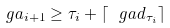Convert formula to latex. <formula><loc_0><loc_0><loc_500><loc_500>\ g a _ { i + 1 } \geq \tau _ { i } + \lceil \ g a d _ { \tau _ { i } } \rceil</formula> 